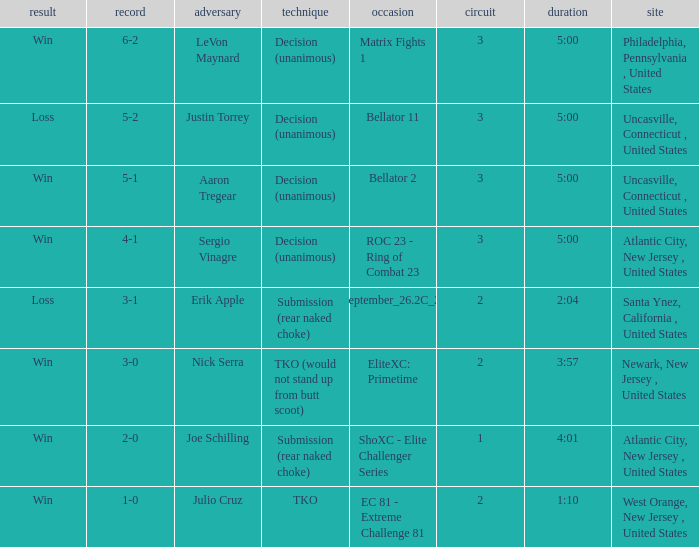What round was it when the method was TKO (would not stand up from Butt Scoot)? 2.0. I'm looking to parse the entire table for insights. Could you assist me with that? {'header': ['result', 'record', 'adversary', 'technique', 'occasion', 'circuit', 'duration', 'site'], 'rows': [['Win', '6-2', 'LeVon Maynard', 'Decision (unanimous)', 'Matrix Fights 1', '3', '5:00', 'Philadelphia, Pennsylvania , United States'], ['Loss', '5-2', 'Justin Torrey', 'Decision (unanimous)', 'Bellator 11', '3', '5:00', 'Uncasville, Connecticut , United States'], ['Win', '5-1', 'Aaron Tregear', 'Decision (unanimous)', 'Bellator 2', '3', '5:00', 'Uncasville, Connecticut , United States'], ['Win', '4-1', 'Sergio Vinagre', 'Decision (unanimous)', 'ROC 23 - Ring of Combat 23', '3', '5:00', 'Atlantic City, New Jersey , United States'], ['Loss', '3-1', 'Erik Apple', 'Submission (rear naked choke)', 'ShoXC#September_26.2C_2008_card', '2', '2:04', 'Santa Ynez, California , United States'], ['Win', '3-0', 'Nick Serra', 'TKO (would not stand up from butt scoot)', 'EliteXC: Primetime', '2', '3:57', 'Newark, New Jersey , United States'], ['Win', '2-0', 'Joe Schilling', 'Submission (rear naked choke)', 'ShoXC - Elite Challenger Series', '1', '4:01', 'Atlantic City, New Jersey , United States'], ['Win', '1-0', 'Julio Cruz', 'TKO', 'EC 81 - Extreme Challenge 81', '2', '1:10', 'West Orange, New Jersey , United States']]} 